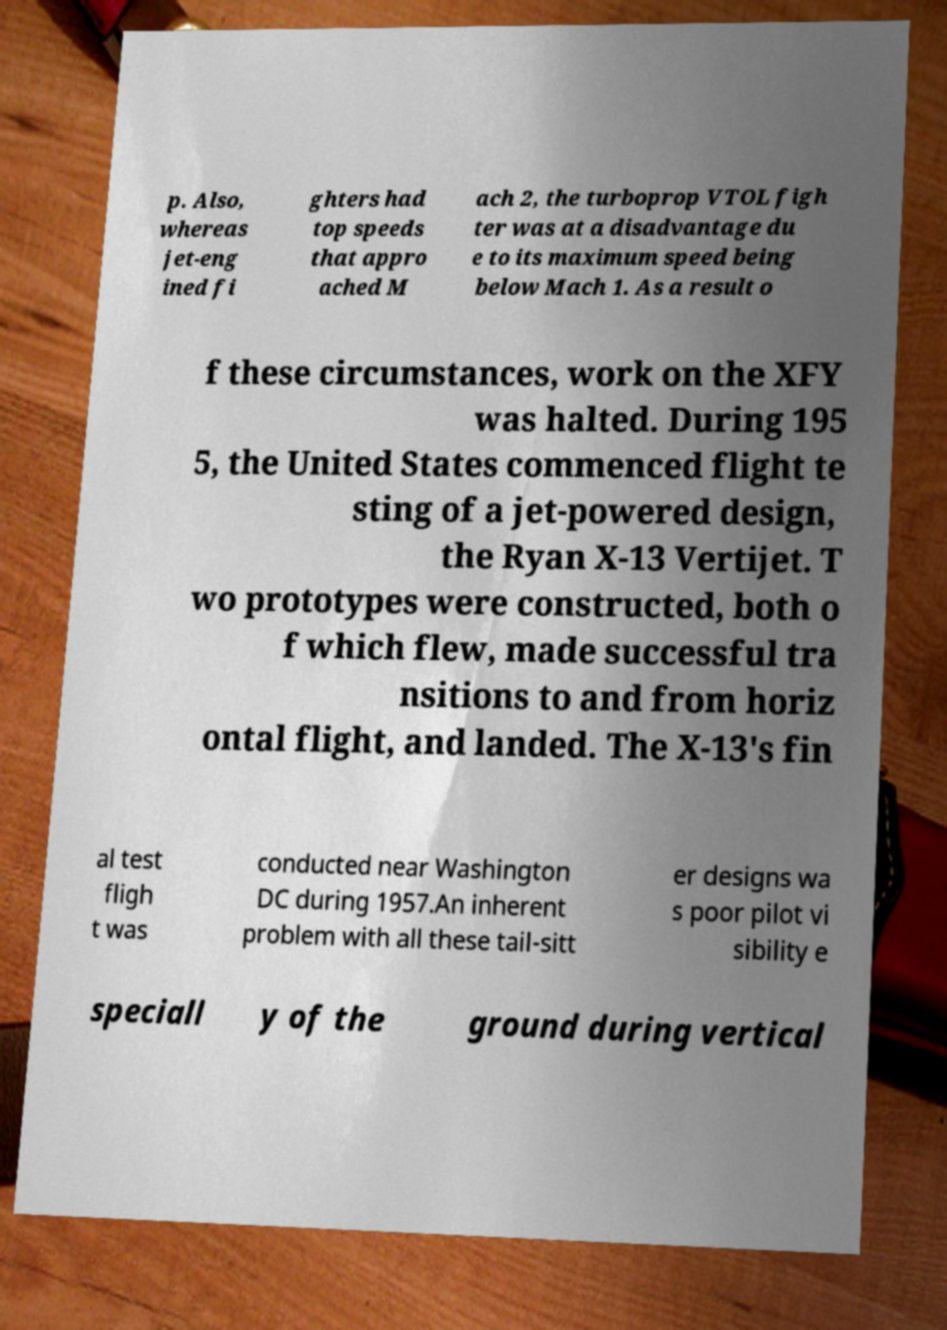What messages or text are displayed in this image? I need them in a readable, typed format. p. Also, whereas jet-eng ined fi ghters had top speeds that appro ached M ach 2, the turboprop VTOL figh ter was at a disadvantage du e to its maximum speed being below Mach 1. As a result o f these circumstances, work on the XFY was halted. During 195 5, the United States commenced flight te sting of a jet-powered design, the Ryan X-13 Vertijet. T wo prototypes were constructed, both o f which flew, made successful tra nsitions to and from horiz ontal flight, and landed. The X-13's fin al test fligh t was conducted near Washington DC during 1957.An inherent problem with all these tail-sitt er designs wa s poor pilot vi sibility e speciall y of the ground during vertical 